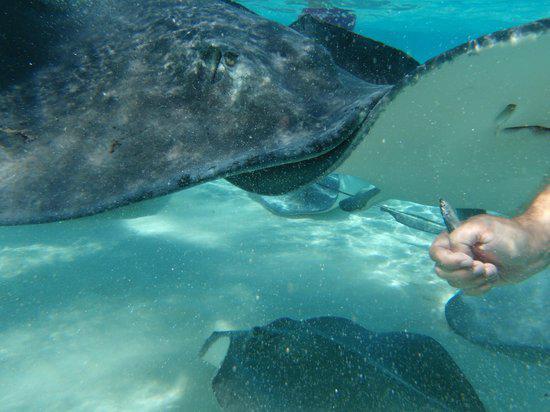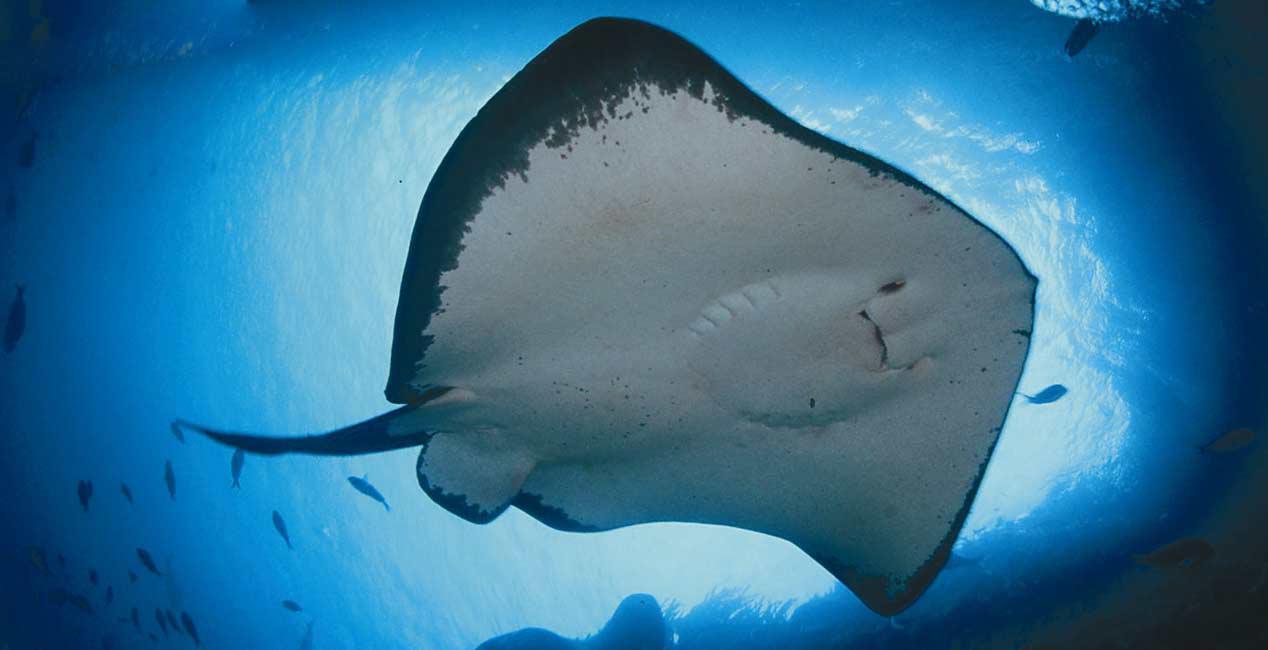The first image is the image on the left, the second image is the image on the right. Considering the images on both sides, is "A human hand is near the underside of a stingray in one image." valid? Answer yes or no. Yes. The first image is the image on the left, the second image is the image on the right. Evaluate the accuracy of this statement regarding the images: "A person is in the water near the sting rays.". Is it true? Answer yes or no. Yes. 